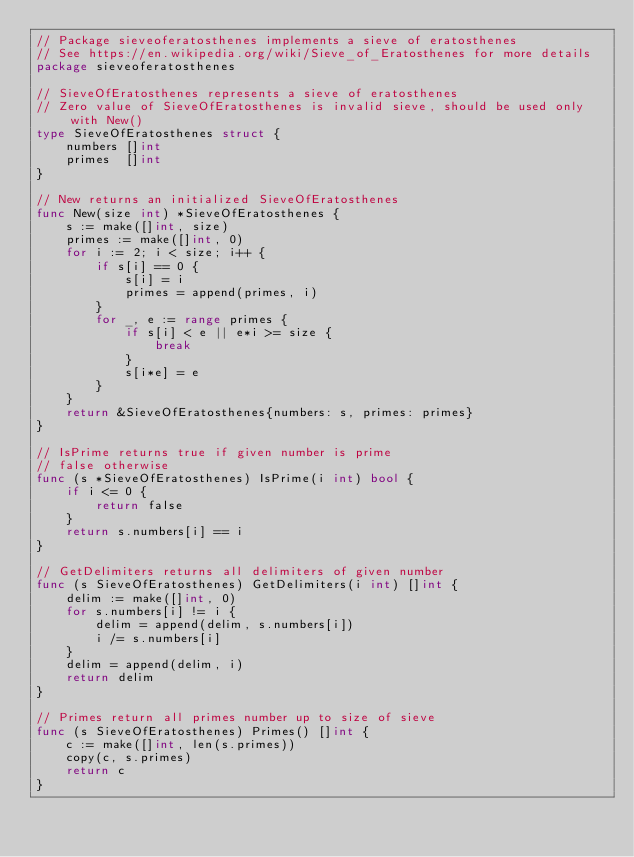Convert code to text. <code><loc_0><loc_0><loc_500><loc_500><_Go_>// Package sieveoferatosthenes implements a sieve of eratosthenes
// See https://en.wikipedia.org/wiki/Sieve_of_Eratosthenes for more details
package sieveoferatosthenes

// SieveOfEratosthenes represents a sieve of eratosthenes
// Zero value of SieveOfEratosthenes is invalid sieve, should be used only with New()
type SieveOfEratosthenes struct {
	numbers []int
	primes  []int
}

// New returns an initialized SieveOfEratosthenes
func New(size int) *SieveOfEratosthenes {
	s := make([]int, size)
	primes := make([]int, 0)
	for i := 2; i < size; i++ {
		if s[i] == 0 {
			s[i] = i
			primes = append(primes, i)
		}
		for _, e := range primes {
			if s[i] < e || e*i >= size {
				break
			}
			s[i*e] = e
		}
	}
	return &SieveOfEratosthenes{numbers: s, primes: primes}
}

// IsPrime returns true if given number is prime
// false otherwise
func (s *SieveOfEratosthenes) IsPrime(i int) bool {
	if i <= 0 {
		return false
	}
	return s.numbers[i] == i
}

// GetDelimiters returns all delimiters of given number
func (s SieveOfEratosthenes) GetDelimiters(i int) []int {
	delim := make([]int, 0)
	for s.numbers[i] != i {
		delim = append(delim, s.numbers[i])
		i /= s.numbers[i]
	}
	delim = append(delim, i)
	return delim
}

// Primes return all primes number up to size of sieve
func (s SieveOfEratosthenes) Primes() []int {
	c := make([]int, len(s.primes))
	copy(c, s.primes)
	return c
}
</code> 